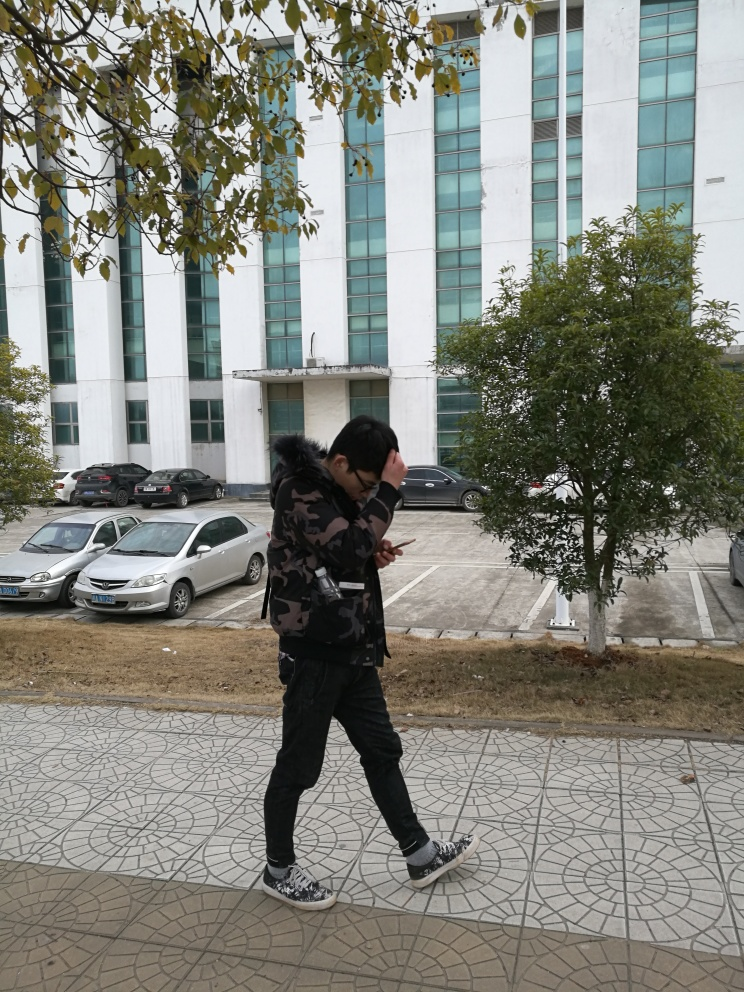What is the lighting like in the image? The lighting in the image appears to be optimal, it’s neither too dim nor excessively bright. The shadows cast by the trees are soft and the visibility is clear, suggesting that the natural light provides good illumination for the scene. 